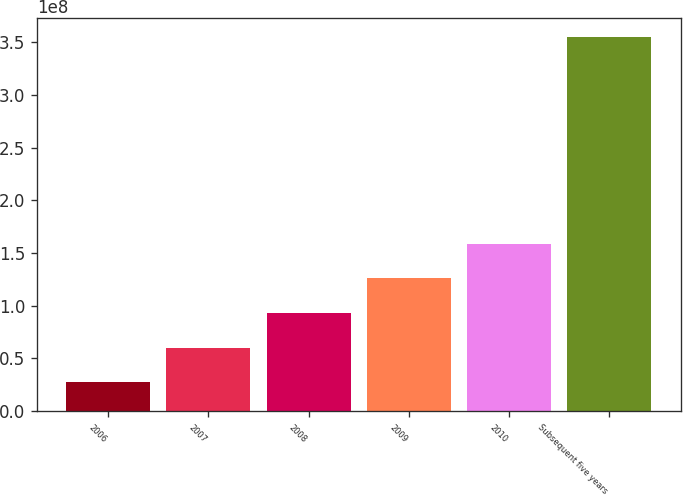Convert chart. <chart><loc_0><loc_0><loc_500><loc_500><bar_chart><fcel>2006<fcel>2007<fcel>2008<fcel>2009<fcel>2010<fcel>Subsequent five years<nl><fcel>2.7316e+07<fcel>6.01394e+07<fcel>9.29628e+07<fcel>1.25786e+08<fcel>1.5861e+08<fcel>3.5555e+08<nl></chart> 